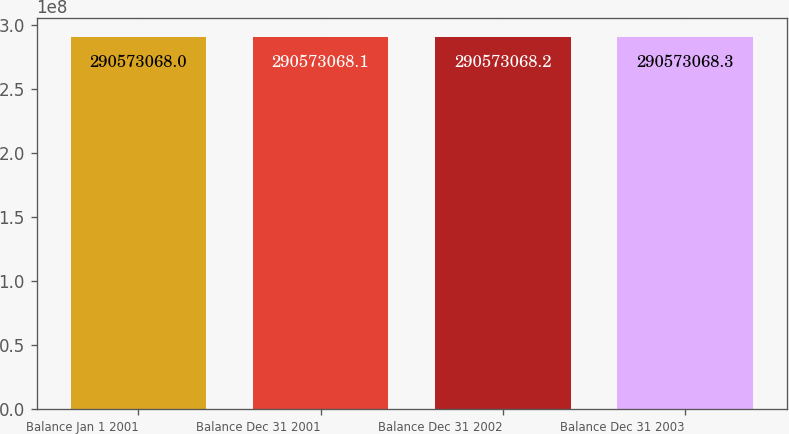<chart> <loc_0><loc_0><loc_500><loc_500><bar_chart><fcel>Balance Jan 1 2001<fcel>Balance Dec 31 2001<fcel>Balance Dec 31 2002<fcel>Balance Dec 31 2003<nl><fcel>2.90573e+08<fcel>2.90573e+08<fcel>2.90573e+08<fcel>2.90573e+08<nl></chart> 